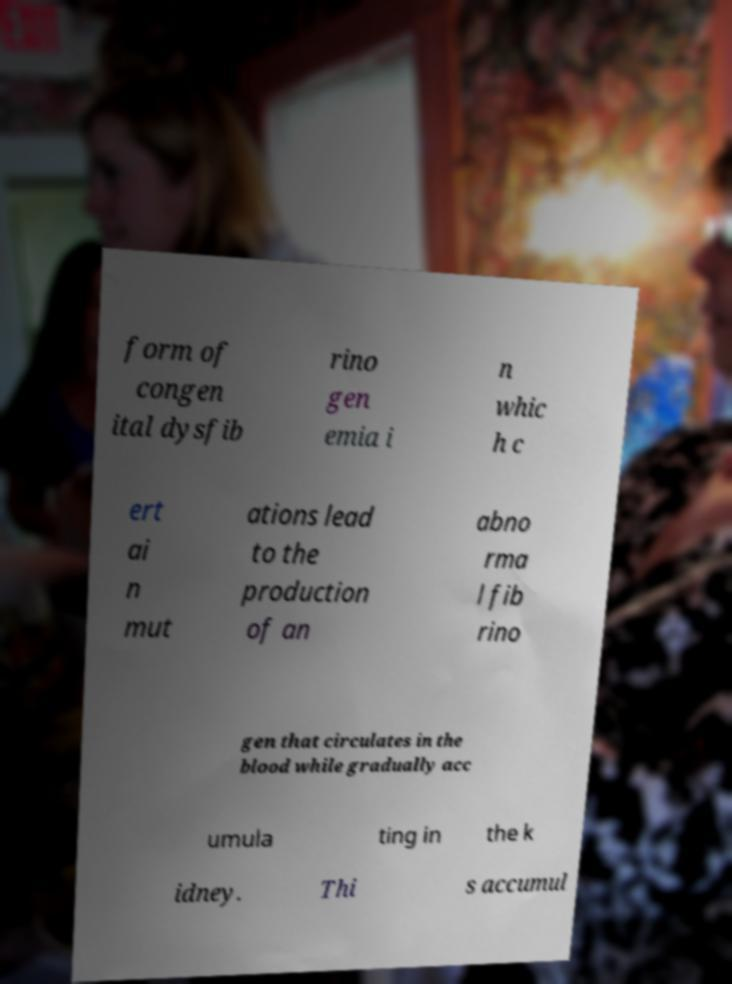Can you accurately transcribe the text from the provided image for me? form of congen ital dysfib rino gen emia i n whic h c ert ai n mut ations lead to the production of an abno rma l fib rino gen that circulates in the blood while gradually acc umula ting in the k idney. Thi s accumul 